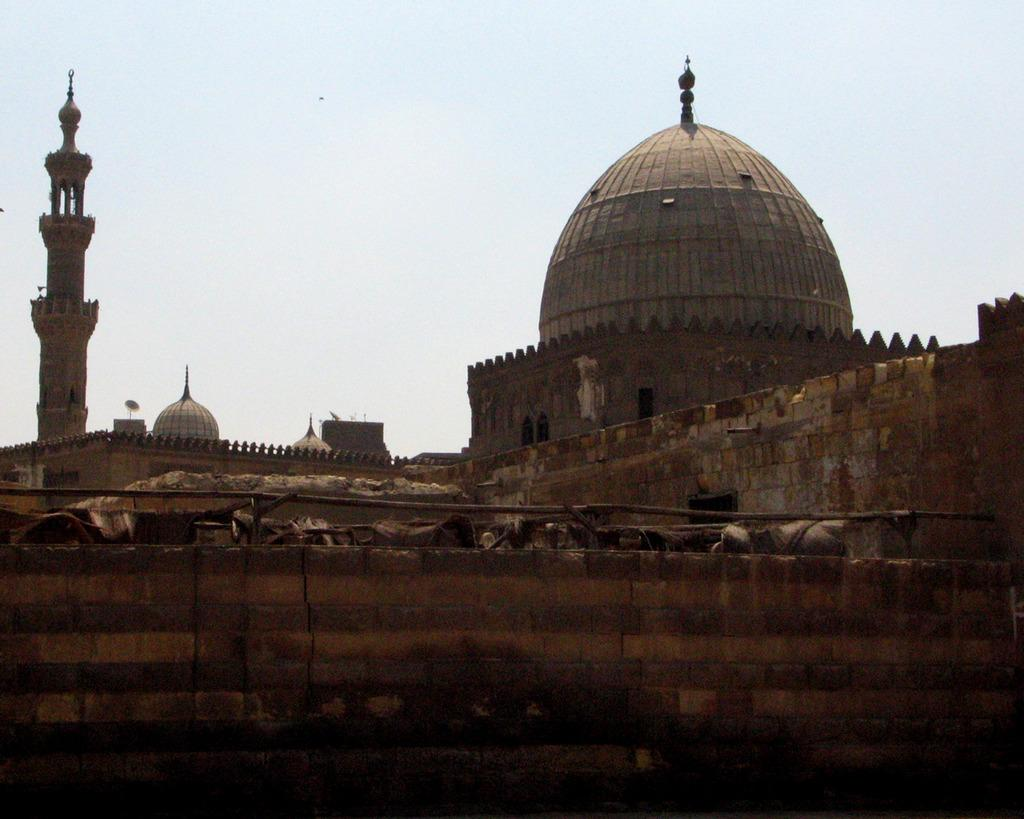What is present in the foreground of the image? There is a wall in the image. What can be seen in the background of the image? There are buildings and a tower in the background of the image. What is visible in the sky in the image? There are clouds in the sky in the image. How many pears are hanging from the wall in the image? There are no pears present in the image; it only features a wall, buildings, a tower, and clouds in the sky. 